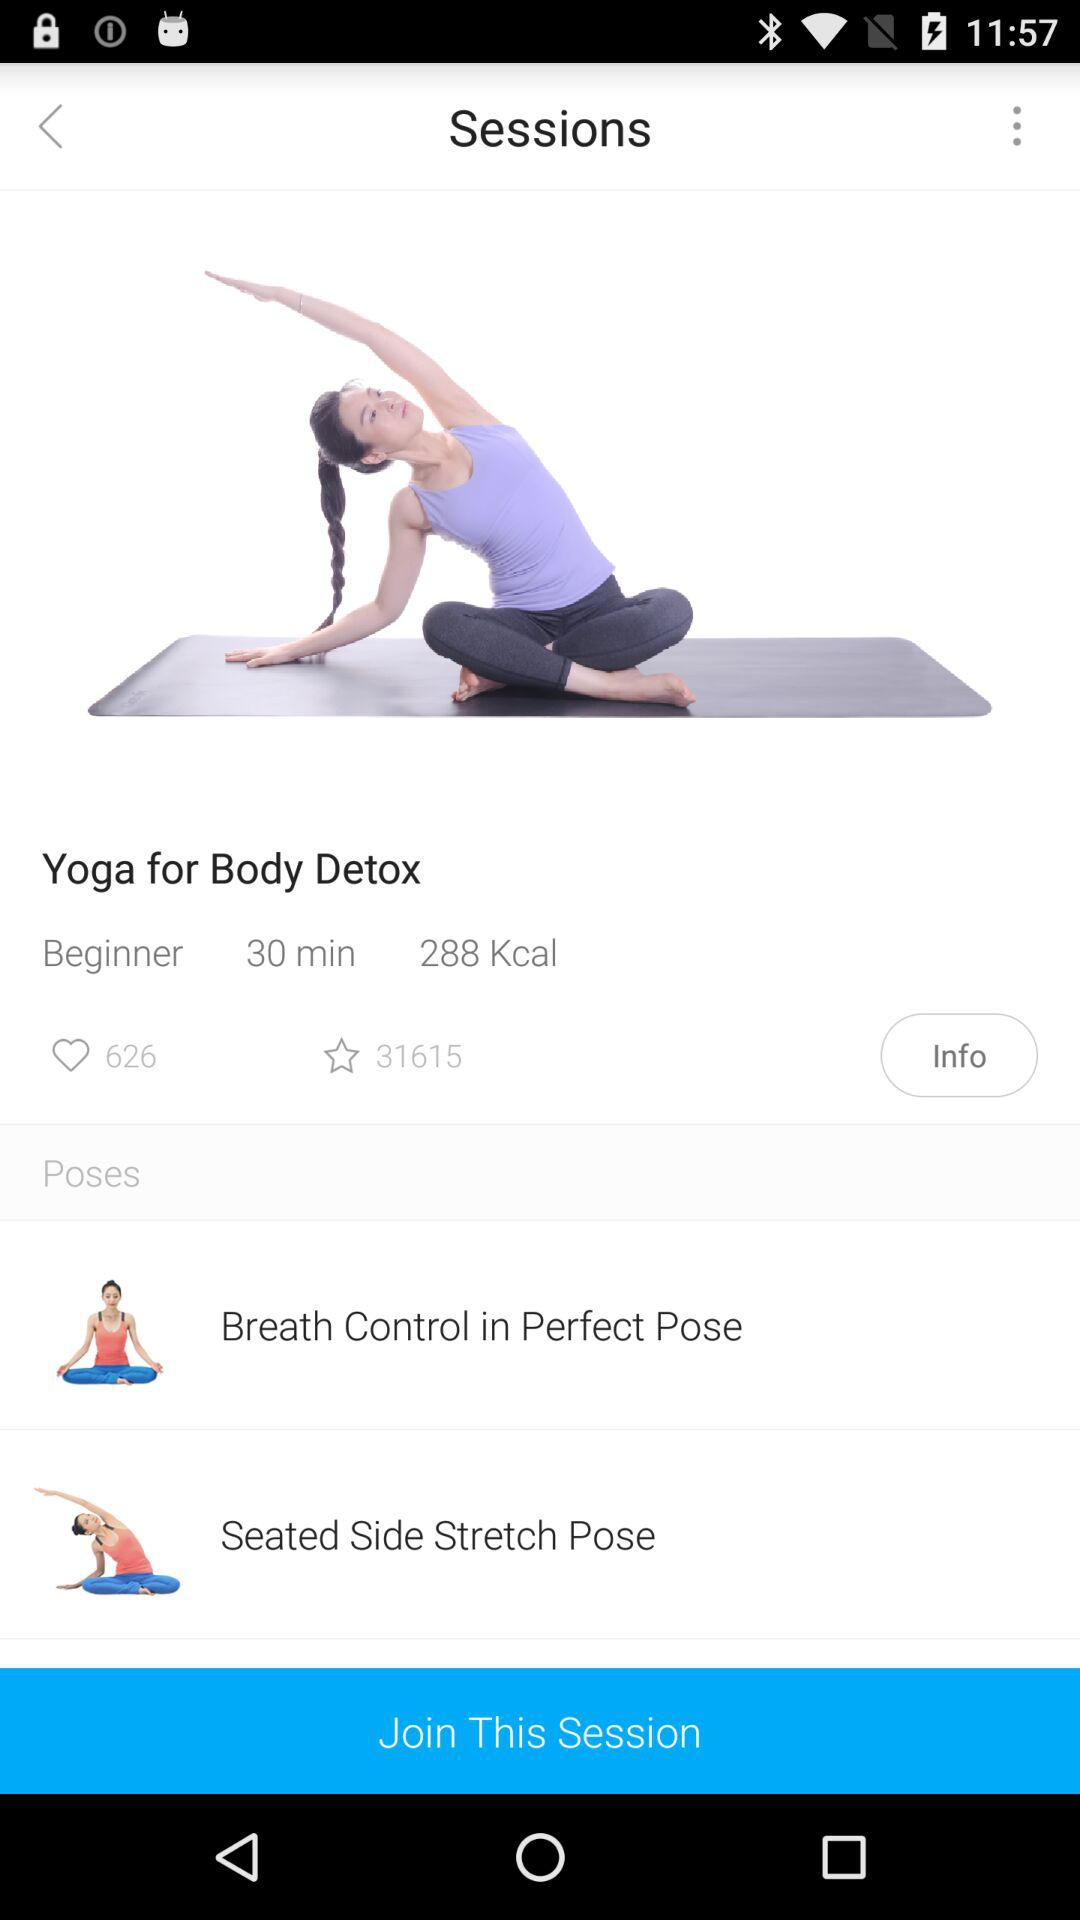How many likes are there? There are 626 likes. 